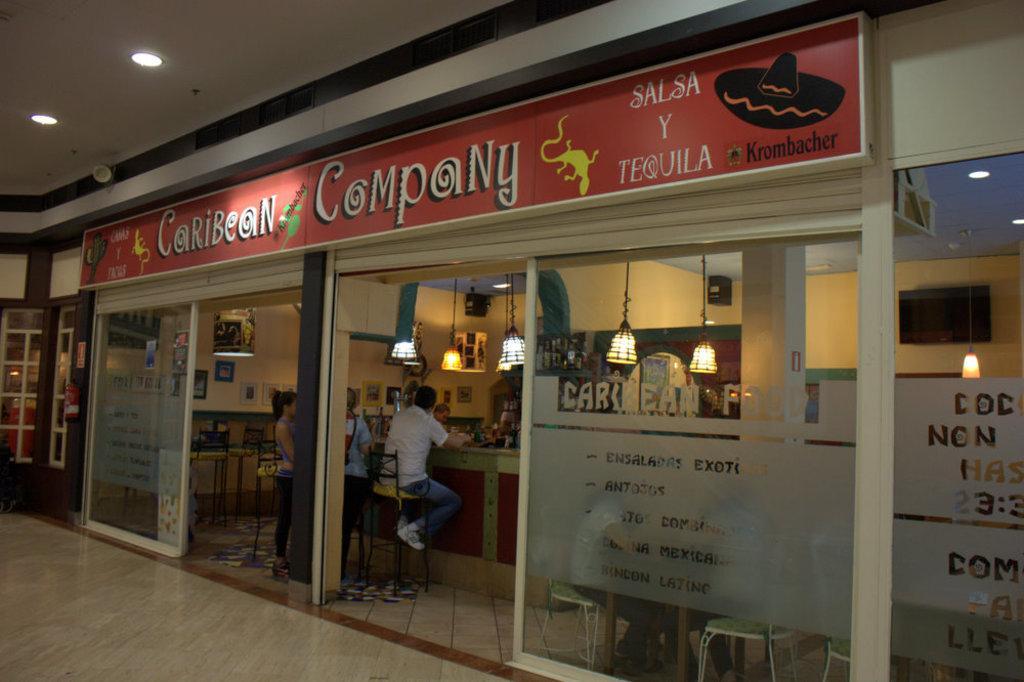How would you summarize this image in a sentence or two? In this image we can see shop with shutters. There are glass walls. On that something is written. Also there is a name board. There are few people sitting on chairs. There are lights. On the ceiling also there are lights. 